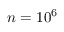<formula> <loc_0><loc_0><loc_500><loc_500>n = 1 0 ^ { 6 }</formula> 